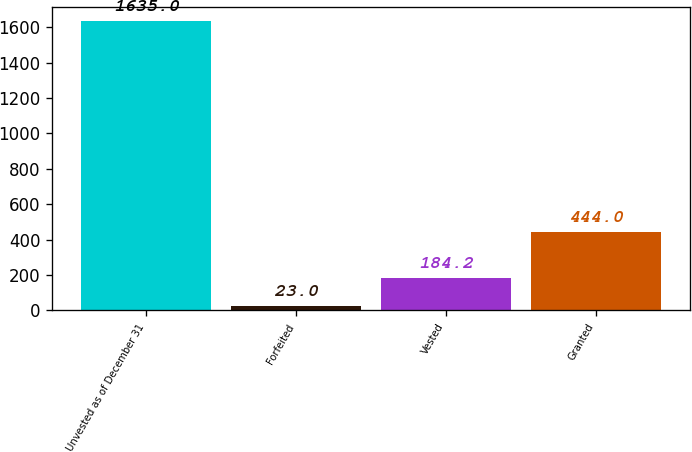Convert chart. <chart><loc_0><loc_0><loc_500><loc_500><bar_chart><fcel>Unvested as of December 31<fcel>Forfeited<fcel>Vested<fcel>Granted<nl><fcel>1635<fcel>23<fcel>184.2<fcel>444<nl></chart> 